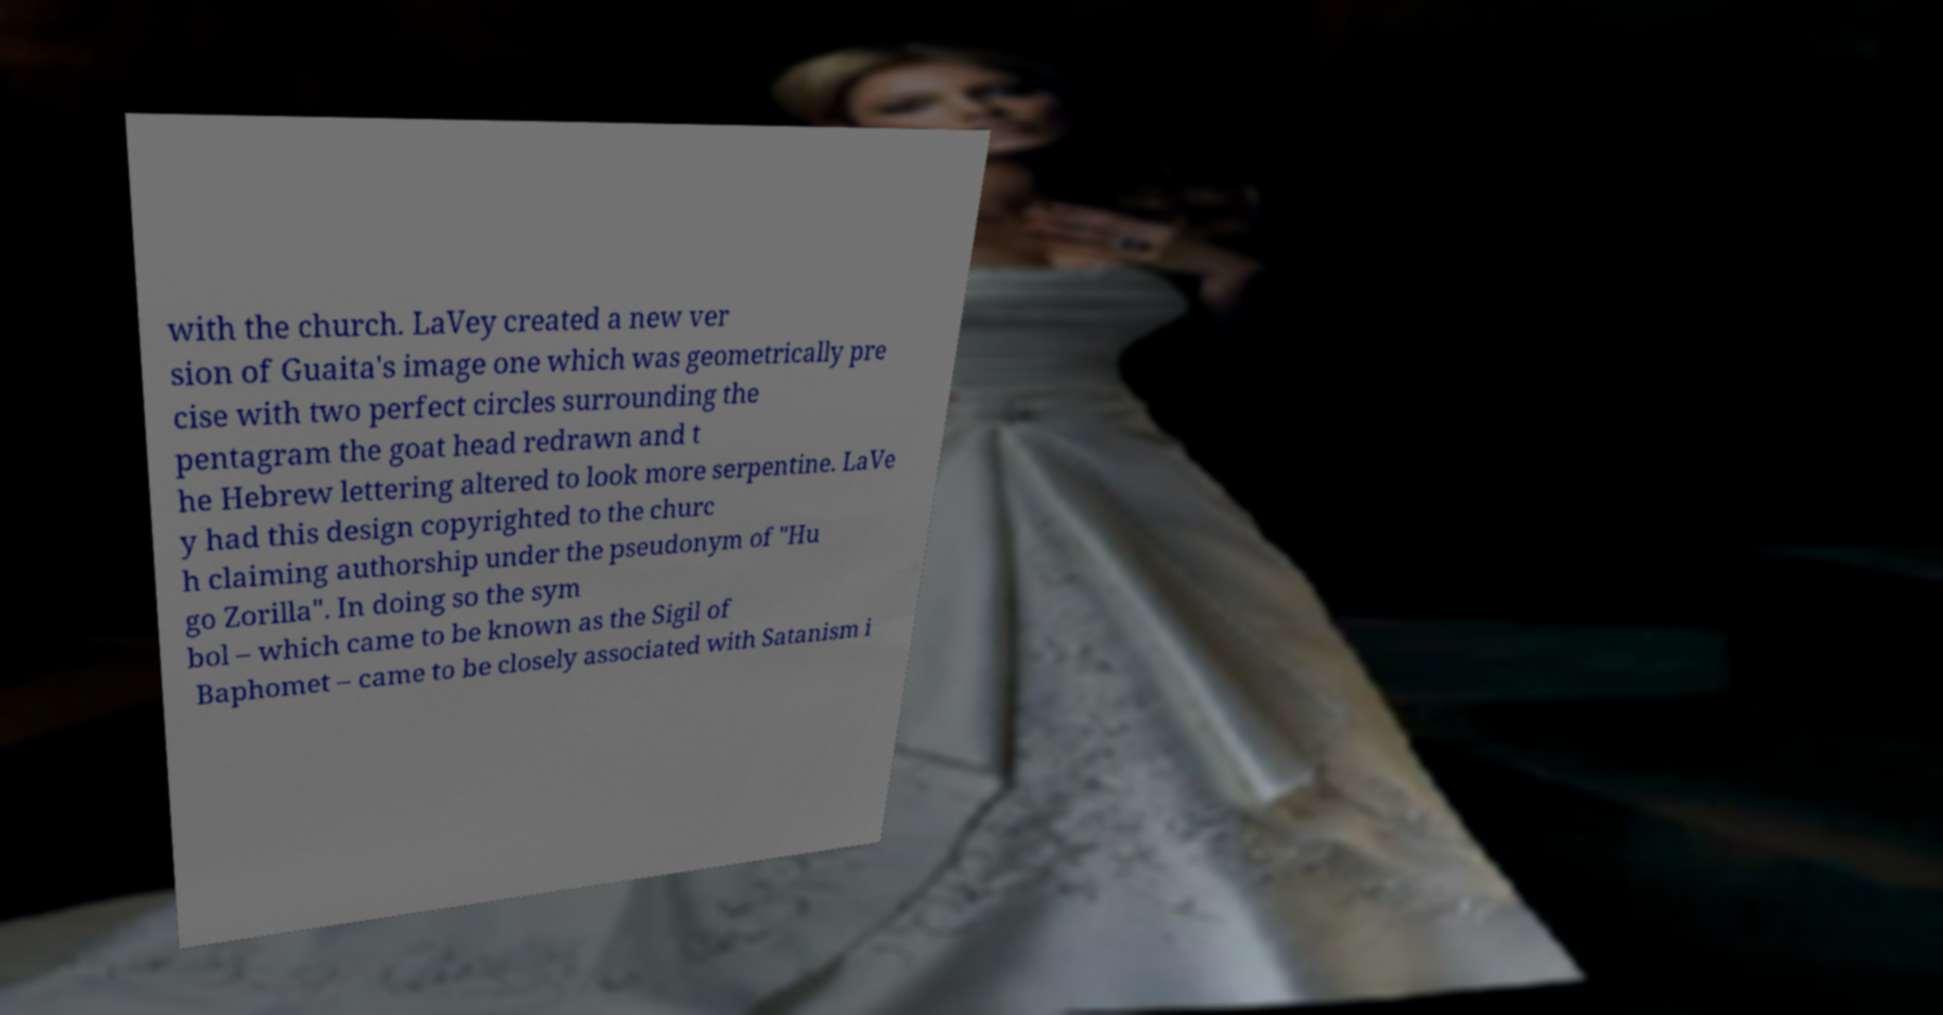Please identify and transcribe the text found in this image. with the church. LaVey created a new ver sion of Guaita's image one which was geometrically pre cise with two perfect circles surrounding the pentagram the goat head redrawn and t he Hebrew lettering altered to look more serpentine. LaVe y had this design copyrighted to the churc h claiming authorship under the pseudonym of "Hu go Zorilla". In doing so the sym bol – which came to be known as the Sigil of Baphomet – came to be closely associated with Satanism i 